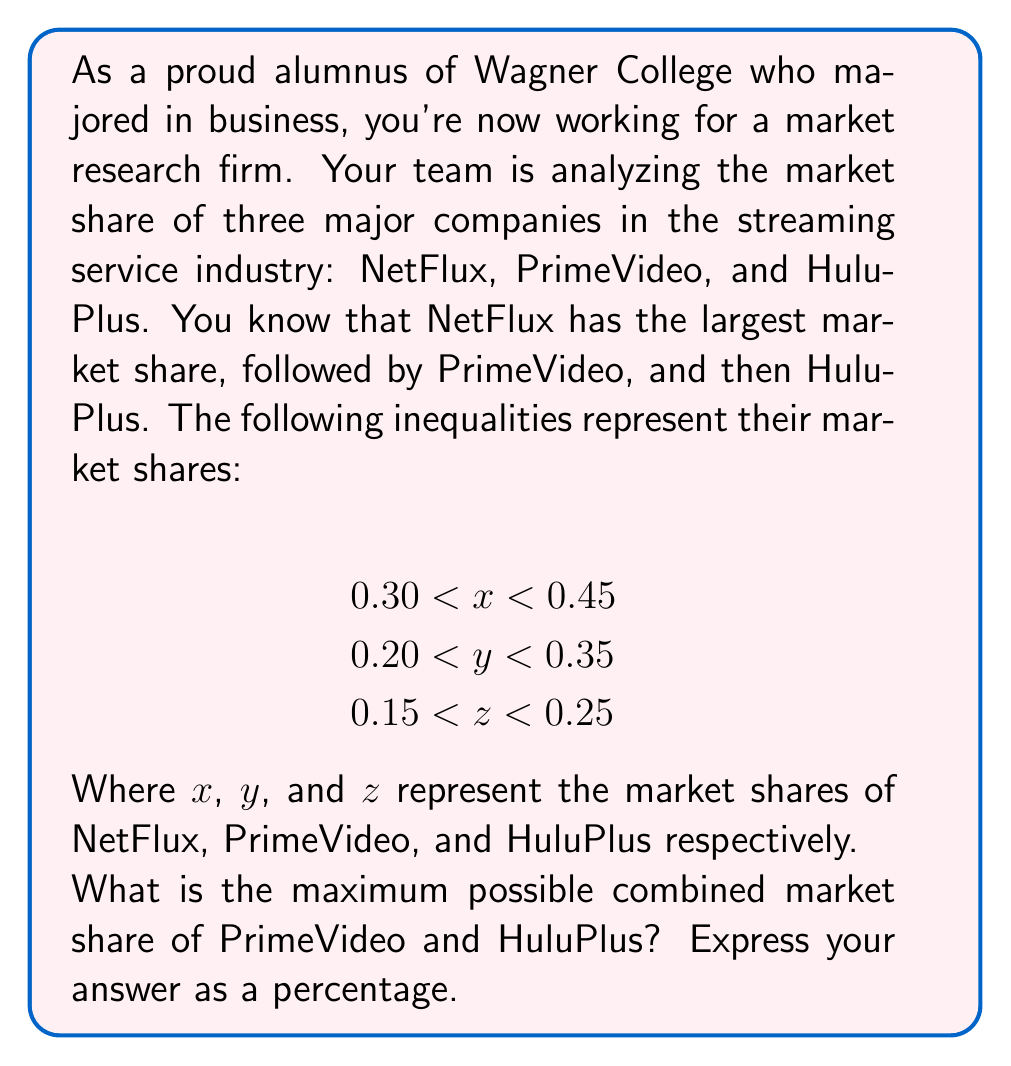Solve this math problem. To solve this problem, we need to follow these steps:

1. Identify the maximum possible market share for PrimeVideo and HuluPlus:
   - For PrimeVideo (y): The maximum is 0.35
   - For HuluPlus (z): The maximum is 0.25

2. Add these maximum values:
   $$ 0.35 + 0.25 = 0.60 $$

3. Convert the decimal to a percentage:
   $$ 0.60 \times 100\% = 60\% $$

This solution uses the upper bounds of the inequalities for PrimeVideo and HuluPlus to find their maximum possible combined market share. We don't need to consider NetFlux's share for this particular question.

It's worth noting that in reality, the actual combined share might be less than this maximum, as the total market share of all companies cannot exceed 100%. However, the question asks for the maximum possible share based on the given inequalities.
Answer: 60% 